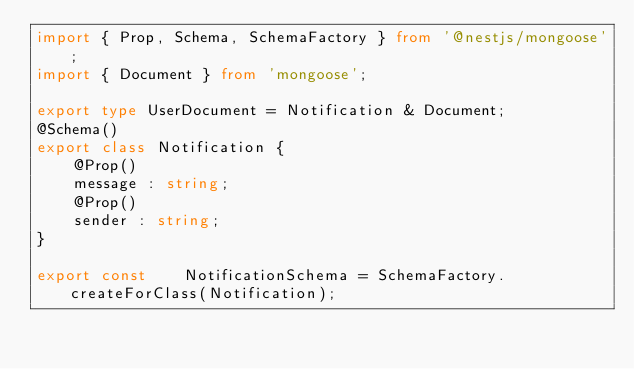Convert code to text. <code><loc_0><loc_0><loc_500><loc_500><_TypeScript_>import { Prop, Schema, SchemaFactory } from '@nestjs/mongoose';
import { Document } from 'mongoose';

export type UserDocument = Notification & Document;
@Schema()
export class Notification {
    @Prop()
    message : string;
    @Prop()
    sender : string;
}

export const    NotificationSchema = SchemaFactory.createForClass(Notification);
</code> 